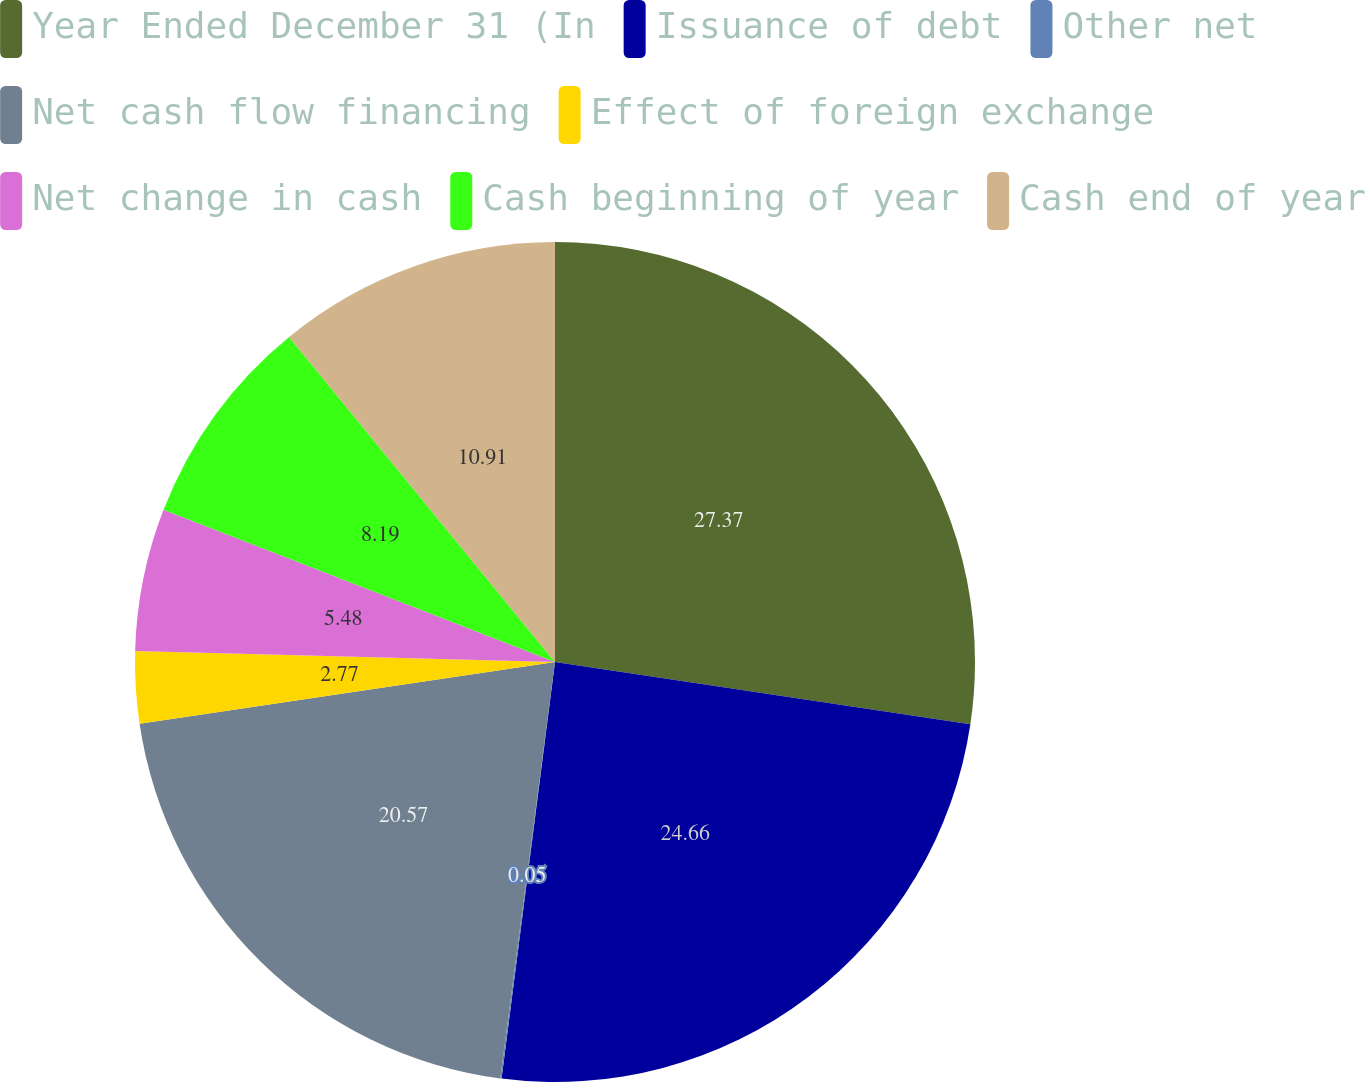Convert chart to OTSL. <chart><loc_0><loc_0><loc_500><loc_500><pie_chart><fcel>Year Ended December 31 (In<fcel>Issuance of debt<fcel>Other net<fcel>Net cash flow financing<fcel>Effect of foreign exchange<fcel>Net change in cash<fcel>Cash beginning of year<fcel>Cash end of year<nl><fcel>27.37%<fcel>24.66%<fcel>0.05%<fcel>20.57%<fcel>2.77%<fcel>5.48%<fcel>8.19%<fcel>10.91%<nl></chart> 